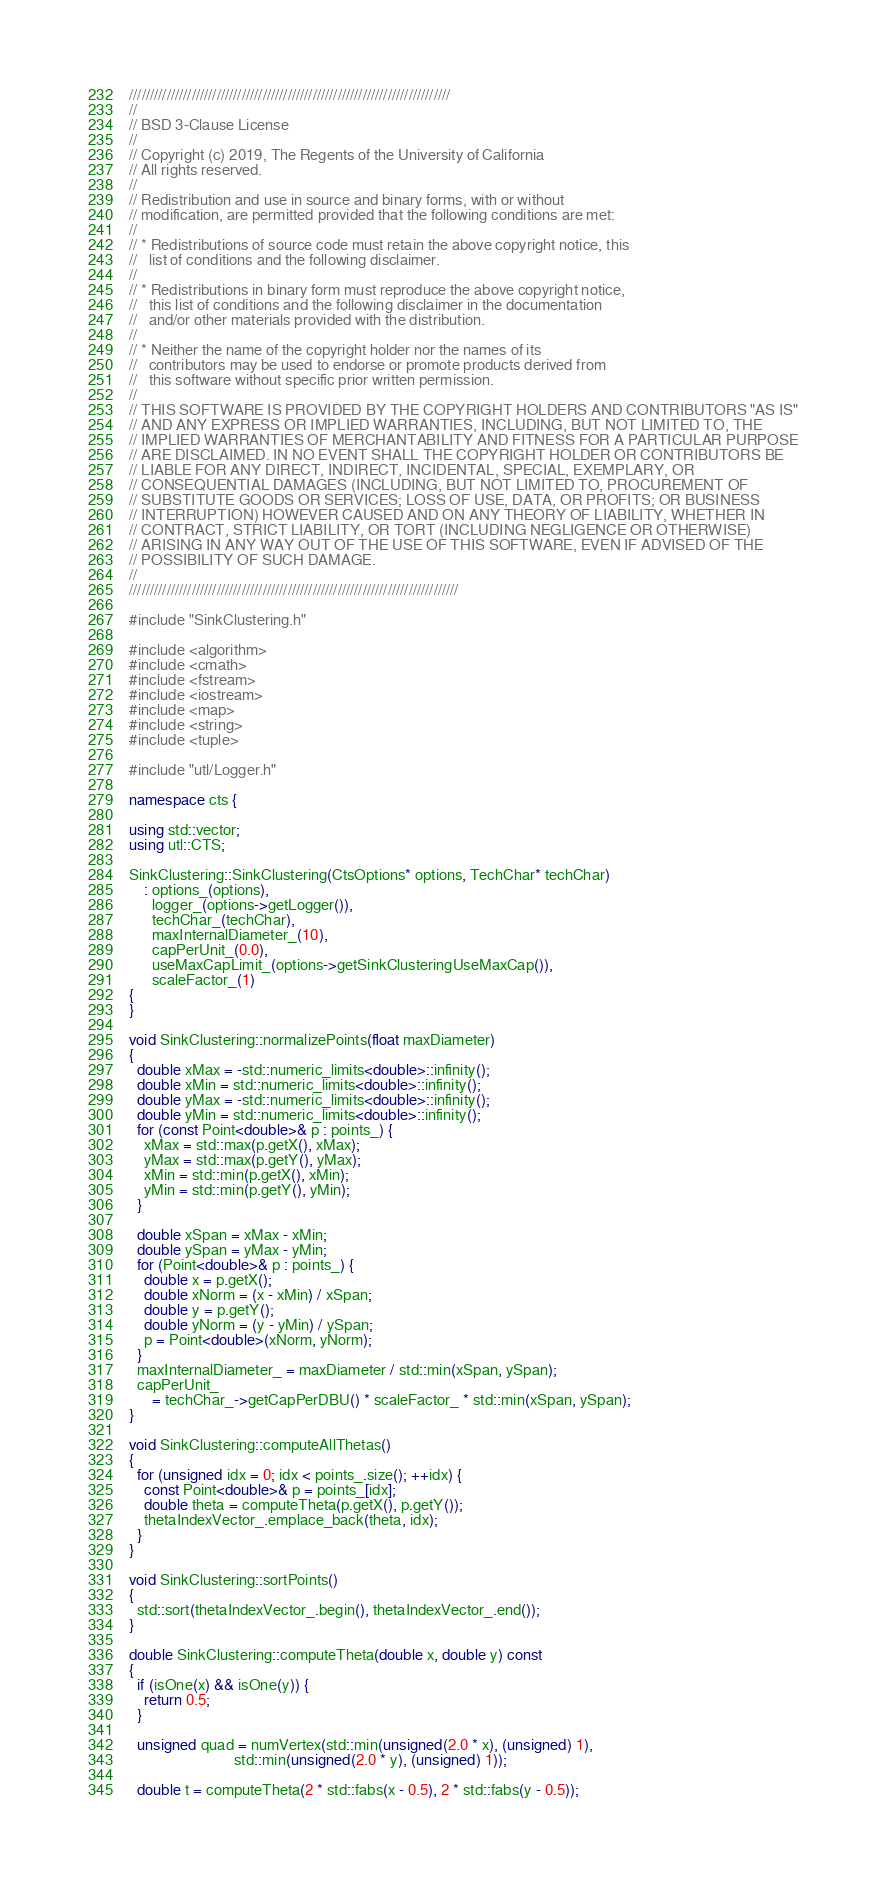Convert code to text. <code><loc_0><loc_0><loc_500><loc_500><_C++_>/////////////////////////////////////////////////////////////////////////////
//
// BSD 3-Clause License
//
// Copyright (c) 2019, The Regents of the University of California
// All rights reserved.
//
// Redistribution and use in source and binary forms, with or without
// modification, are permitted provided that the following conditions are met:
//
// * Redistributions of source code must retain the above copyright notice, this
//   list of conditions and the following disclaimer.
//
// * Redistributions in binary form must reproduce the above copyright notice,
//   this list of conditions and the following disclaimer in the documentation
//   and/or other materials provided with the distribution.
//
// * Neither the name of the copyright holder nor the names of its
//   contributors may be used to endorse or promote products derived from
//   this software without specific prior written permission.
//
// THIS SOFTWARE IS PROVIDED BY THE COPYRIGHT HOLDERS AND CONTRIBUTORS "AS IS"
// AND ANY EXPRESS OR IMPLIED WARRANTIES, INCLUDING, BUT NOT LIMITED TO, THE
// IMPLIED WARRANTIES OF MERCHANTABILITY AND FITNESS FOR A PARTICULAR PURPOSE
// ARE DISCLAIMED. IN NO EVENT SHALL THE COPYRIGHT HOLDER OR CONTRIBUTORS BE
// LIABLE FOR ANY DIRECT, INDIRECT, INCIDENTAL, SPECIAL, EXEMPLARY, OR
// CONSEQUENTIAL DAMAGES (INCLUDING, BUT NOT LIMITED TO, PROCUREMENT OF
// SUBSTITUTE GOODS OR SERVICES; LOSS OF USE, DATA, OR PROFITS; OR BUSINESS
// INTERRUPTION) HOWEVER CAUSED AND ON ANY THEORY OF LIABILITY, WHETHER IN
// CONTRACT, STRICT LIABILITY, OR TORT (INCLUDING NEGLIGENCE OR OTHERWISE)
// ARISING IN ANY WAY OUT OF THE USE OF THIS SOFTWARE, EVEN IF ADVISED OF THE
// POSSIBILITY OF SUCH DAMAGE.
//
///////////////////////////////////////////////////////////////////////////////

#include "SinkClustering.h"

#include <algorithm>
#include <cmath>
#include <fstream>
#include <iostream>
#include <map>
#include <string>
#include <tuple>

#include "utl/Logger.h"

namespace cts {

using std::vector;
using utl::CTS;

SinkClustering::SinkClustering(CtsOptions* options, TechChar* techChar)
    : options_(options),
      logger_(options->getLogger()),
      techChar_(techChar),
      maxInternalDiameter_(10),
      capPerUnit_(0.0),
      useMaxCapLimit_(options->getSinkClusteringUseMaxCap()),
      scaleFactor_(1)
{
}

void SinkClustering::normalizePoints(float maxDiameter)
{
  double xMax = -std::numeric_limits<double>::infinity();
  double xMin = std::numeric_limits<double>::infinity();
  double yMax = -std::numeric_limits<double>::infinity();
  double yMin = std::numeric_limits<double>::infinity();
  for (const Point<double>& p : points_) {
    xMax = std::max(p.getX(), xMax);
    yMax = std::max(p.getY(), yMax);
    xMin = std::min(p.getX(), xMin);
    yMin = std::min(p.getY(), yMin);
  }

  double xSpan = xMax - xMin;
  double ySpan = yMax - yMin;
  for (Point<double>& p : points_) {
    double x = p.getX();
    double xNorm = (x - xMin) / xSpan;
    double y = p.getY();
    double yNorm = (y - yMin) / ySpan;
    p = Point<double>(xNorm, yNorm);
  }
  maxInternalDiameter_ = maxDiameter / std::min(xSpan, ySpan);
  capPerUnit_
      = techChar_->getCapPerDBU() * scaleFactor_ * std::min(xSpan, ySpan);
}

void SinkClustering::computeAllThetas()
{
  for (unsigned idx = 0; idx < points_.size(); ++idx) {
    const Point<double>& p = points_[idx];
    double theta = computeTheta(p.getX(), p.getY());
    thetaIndexVector_.emplace_back(theta, idx);
  }
}

void SinkClustering::sortPoints()
{
  std::sort(thetaIndexVector_.begin(), thetaIndexVector_.end());
}

double SinkClustering::computeTheta(double x, double y) const
{
  if (isOne(x) && isOne(y)) {
    return 0.5;
  }

  unsigned quad = numVertex(std::min(unsigned(2.0 * x), (unsigned) 1),
                            std::min(unsigned(2.0 * y), (unsigned) 1));

  double t = computeTheta(2 * std::fabs(x - 0.5), 2 * std::fabs(y - 0.5));
</code> 